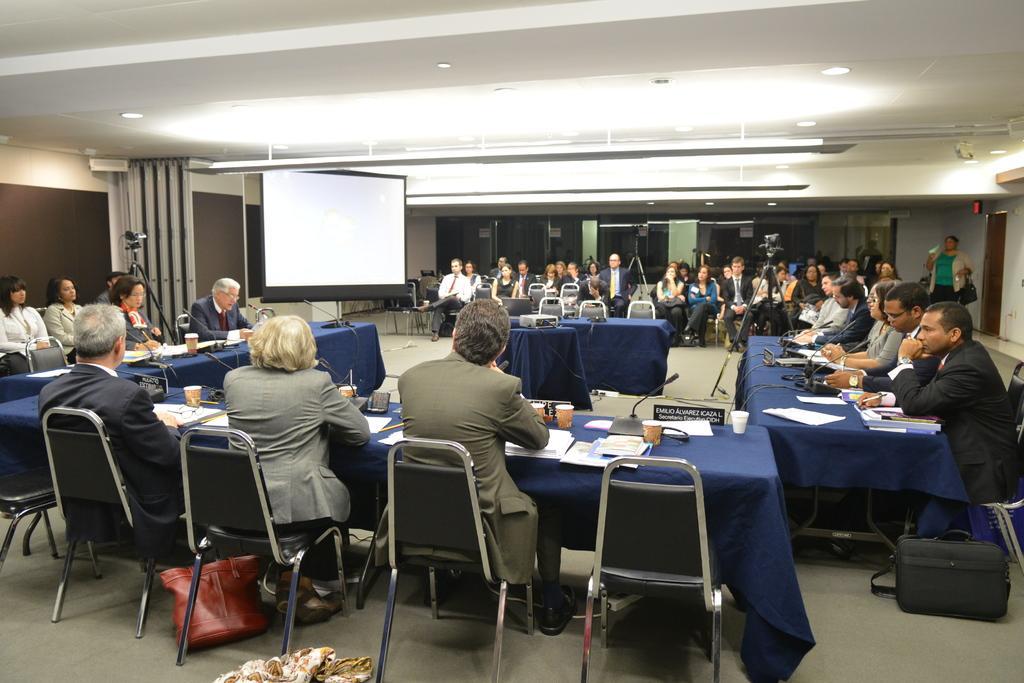Could you give a brief overview of what you see in this image? In a room there are lot of people sitting on chairs in front of tables talking on a micro phone. 